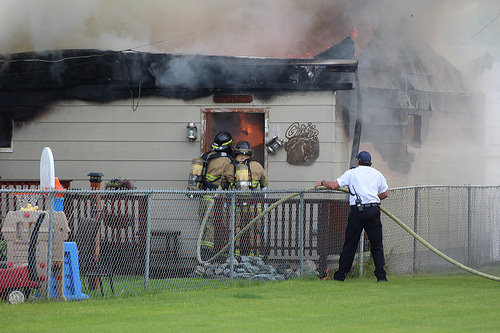<image>
Can you confirm if the man is behind the fence? Yes. From this viewpoint, the man is positioned behind the fence, with the fence partially or fully occluding the man. 